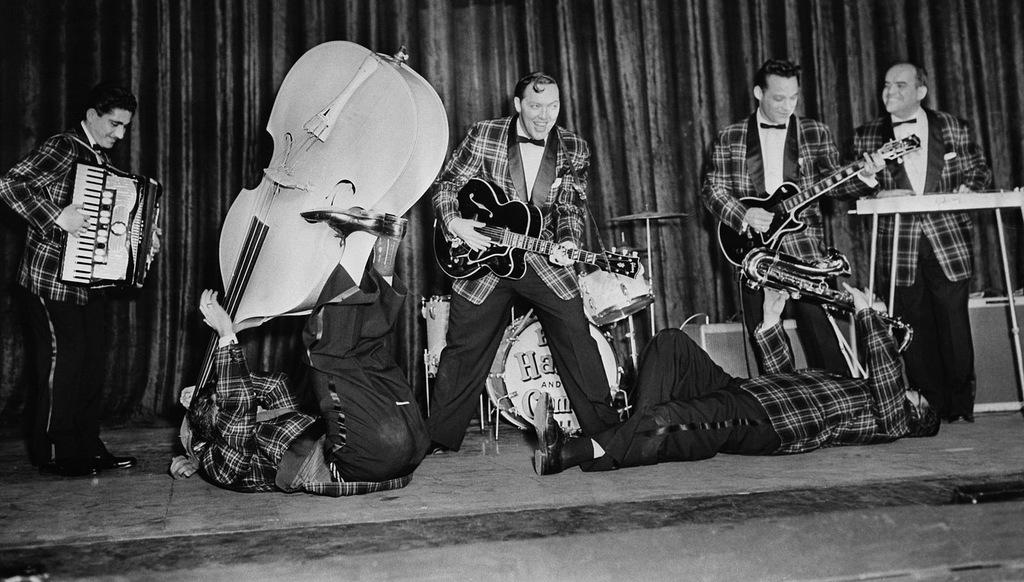What is the color scheme of the image? The image is black and white. What are the persons in the image doing? The persons are playing musical instruments. Can you describe the position of one of the persons playing a musical instrument? There is a person lying on the floor while playing a musical instrument. How many houses can be seen in the image? There are no houses present in the image. What type of movement is required to play the musical instrument while lying on the floor? The person lying on the floor while playing a musical instrument may need to adjust their position or use their limbs to play the instrument, but the question of movement is not directly related to the image. 